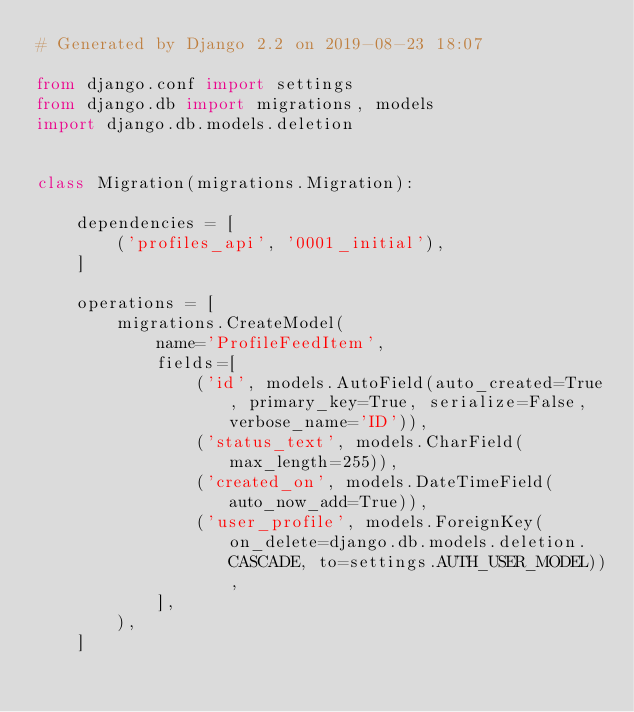<code> <loc_0><loc_0><loc_500><loc_500><_Python_># Generated by Django 2.2 on 2019-08-23 18:07

from django.conf import settings
from django.db import migrations, models
import django.db.models.deletion


class Migration(migrations.Migration):

    dependencies = [
        ('profiles_api', '0001_initial'),
    ]

    operations = [
        migrations.CreateModel(
            name='ProfileFeedItem',
            fields=[
                ('id', models.AutoField(auto_created=True, primary_key=True, serialize=False, verbose_name='ID')),
                ('status_text', models.CharField(max_length=255)),
                ('created_on', models.DateTimeField(auto_now_add=True)),
                ('user_profile', models.ForeignKey(on_delete=django.db.models.deletion.CASCADE, to=settings.AUTH_USER_MODEL)),
            ],
        ),
    ]
</code> 